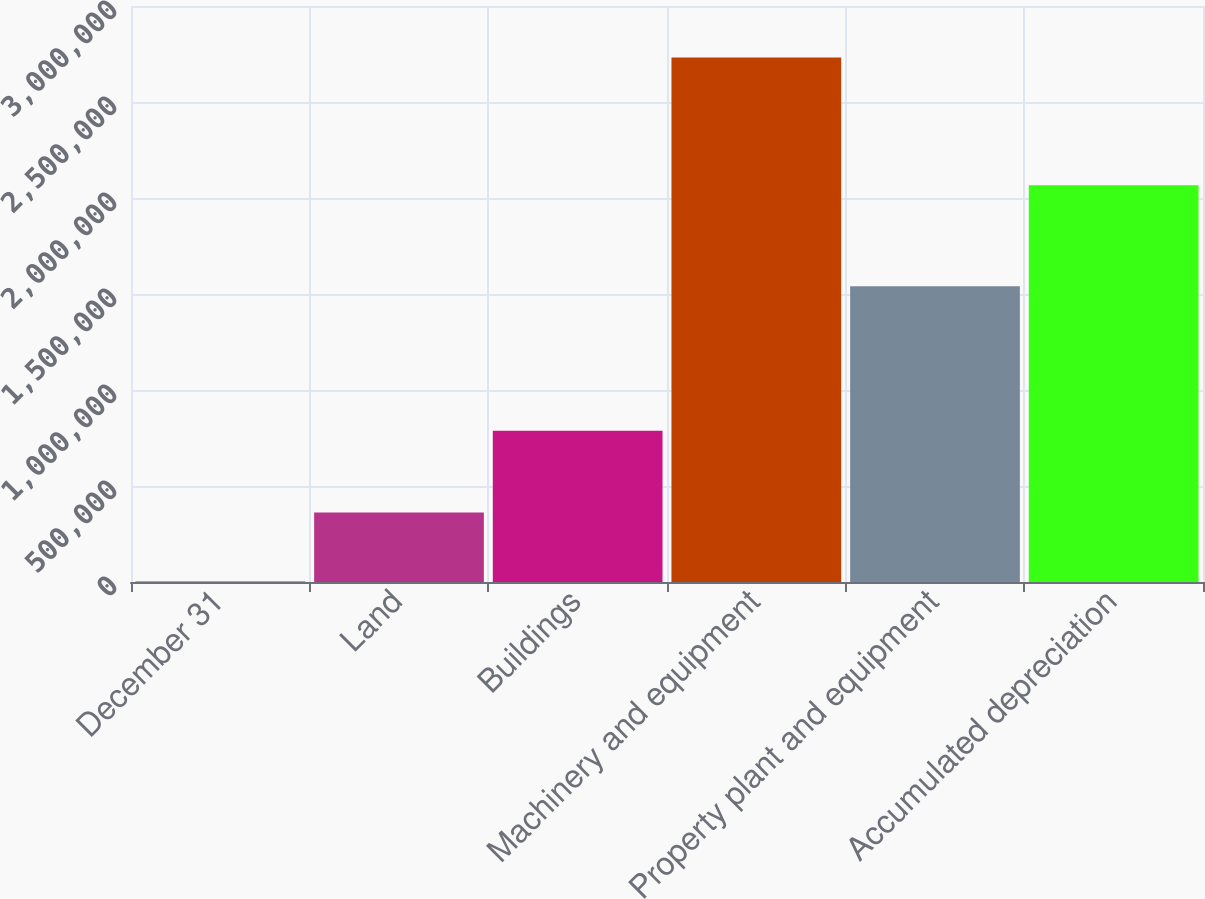Convert chart to OTSL. <chart><loc_0><loc_0><loc_500><loc_500><bar_chart><fcel>December 31<fcel>Land<fcel>Buildings<fcel>Machinery and equipment<fcel>Property plant and equipment<fcel>Accumulated depreciation<nl><fcel>2007<fcel>362451<fcel>788267<fcel>2.73158e+06<fcel>1.53972e+06<fcel>2.06673e+06<nl></chart> 